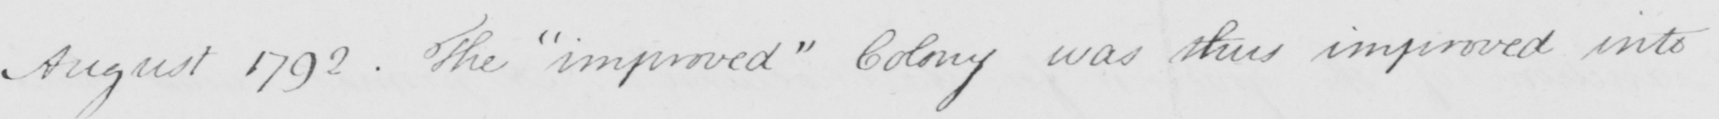What does this handwritten line say? August 1792 . The  " improved "  Colony was thus improved into 